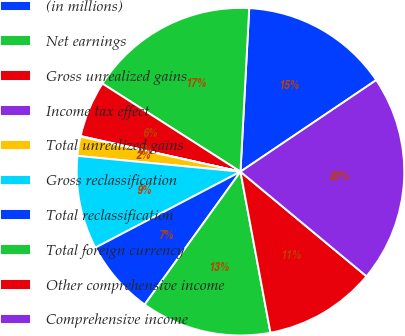Convert chart. <chart><loc_0><loc_0><loc_500><loc_500><pie_chart><fcel>(in millions)<fcel>Net earnings<fcel>Gross unrealized gains<fcel>Income tax effect<fcel>Total unrealized gains<fcel>Gross reclassification<fcel>Total reclassification<fcel>Total foreign currency<fcel>Other comprehensive income<fcel>Comprehensive income<nl><fcel>14.7%<fcel>16.81%<fcel>5.55%<fcel>0.06%<fcel>1.89%<fcel>9.21%<fcel>7.38%<fcel>12.87%<fcel>11.04%<fcel>20.47%<nl></chart> 